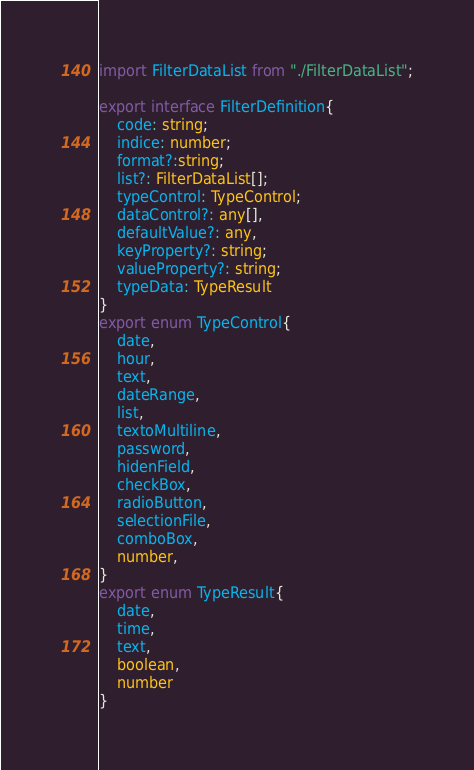<code> <loc_0><loc_0><loc_500><loc_500><_TypeScript_>import FilterDataList from "./FilterDataList";

export interface FilterDefinition{
    code: string;
    indice: number;
    format?:string;
    list?: FilterDataList[];
    typeControl: TypeControl;
    dataControl?: any[],
    defaultValue?: any,
    keyProperty?: string;
    valueProperty?: string;
    typeData: TypeResult
}
export enum TypeControl{
    date,
    hour,
    text,
    dateRange,
    list,
    textoMultiline,
    password,
    hidenField,
    checkBox,
    radioButton,
    selectionFile,
    comboBox,
    number,
}
export enum TypeResult{
    date,
    time,
    text,
    boolean,
    number
}</code> 